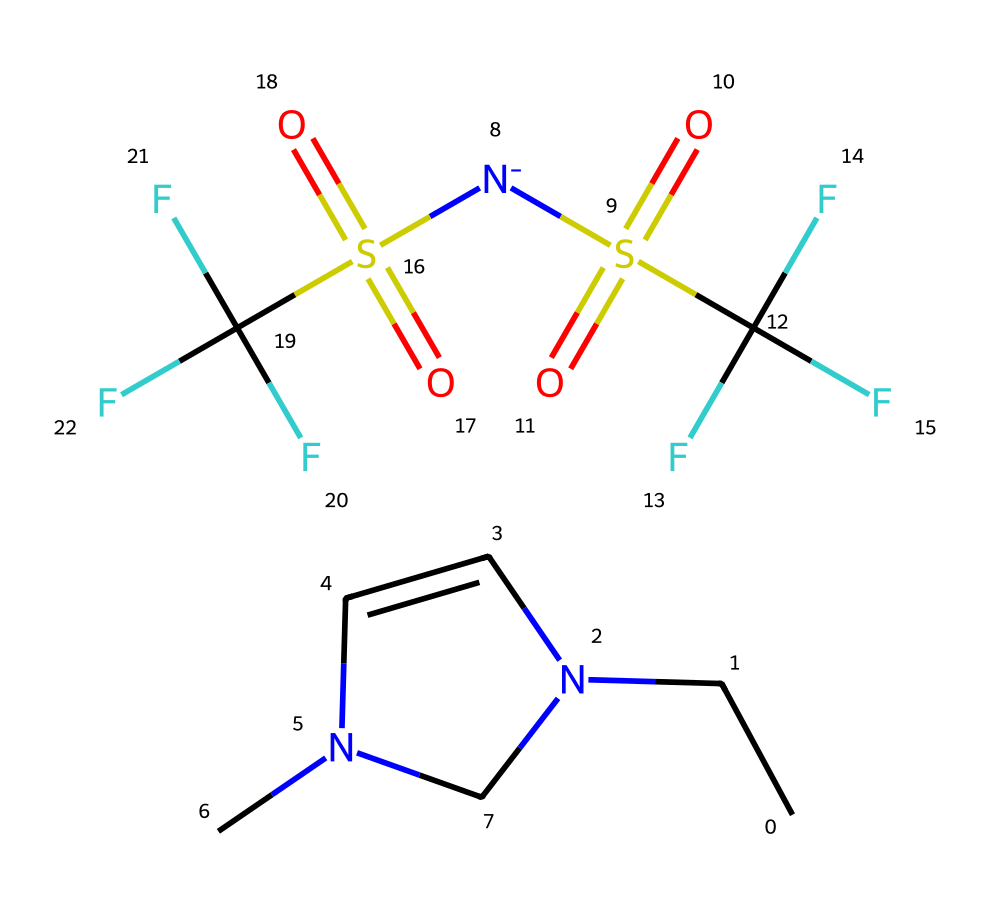What is the primary cation in this ionic liquid? The structure contains the part CCN1C=CN(C)C1 which indicates a nitrogen heterocycle with the alkyl group, typical of a cationic form, specifically a pyrrolidinium or similar cation.
Answer: pyrrolidinium How many fluorine atoms are present in this ionic liquid? The structure includes the part C(F)(F)F which shows three fluorine atoms attached to the carbon. This is confirmed twice in the chemical because it appears in two [N-](S(=O)(=O)C(F)(F)F) groups.
Answer: six What is the general charge of this ionic liquid? The presence of both cation (from the nitrogen-containing part) and anion indicated by the sulfonyl groups means that the overall charge balances; typically these components yield a net zero charge.
Answer: neutral What functional groups can be identified in this ionic liquid? The structure shows sulfonyl groups (S(=O)(=O)) and fluorinated groups (C(F)(F)F), both indicating specific functional characteristics such as strong polarity and potentially higher stability or reactivity.
Answer: sulfonyl, fluorinated How does the presence of fluorine influence the properties of this ionic liquid? Fluorine's high electronegativity affects the chemical reactivity and polarity, leading to properties such as higher thermal stability and lower volatility, which are beneficial for battery applications.
Answer: stability, low volatility 